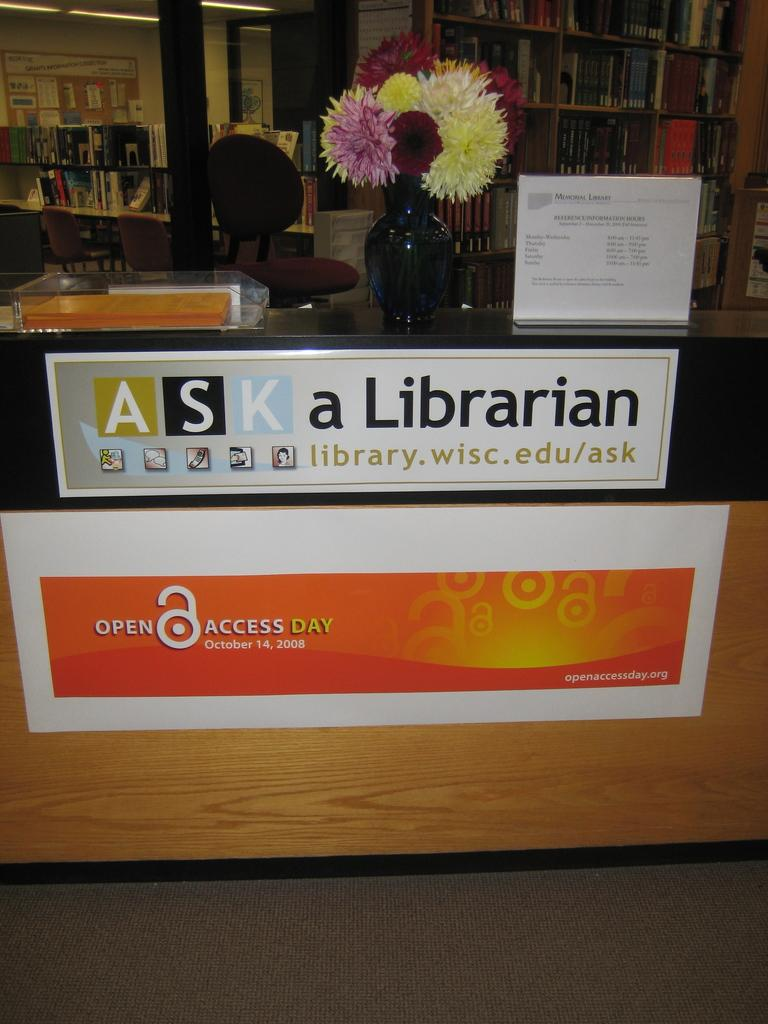<image>
Share a concise interpretation of the image provided. Inside a library, a banner announces the Open Access Day event on October 14. 